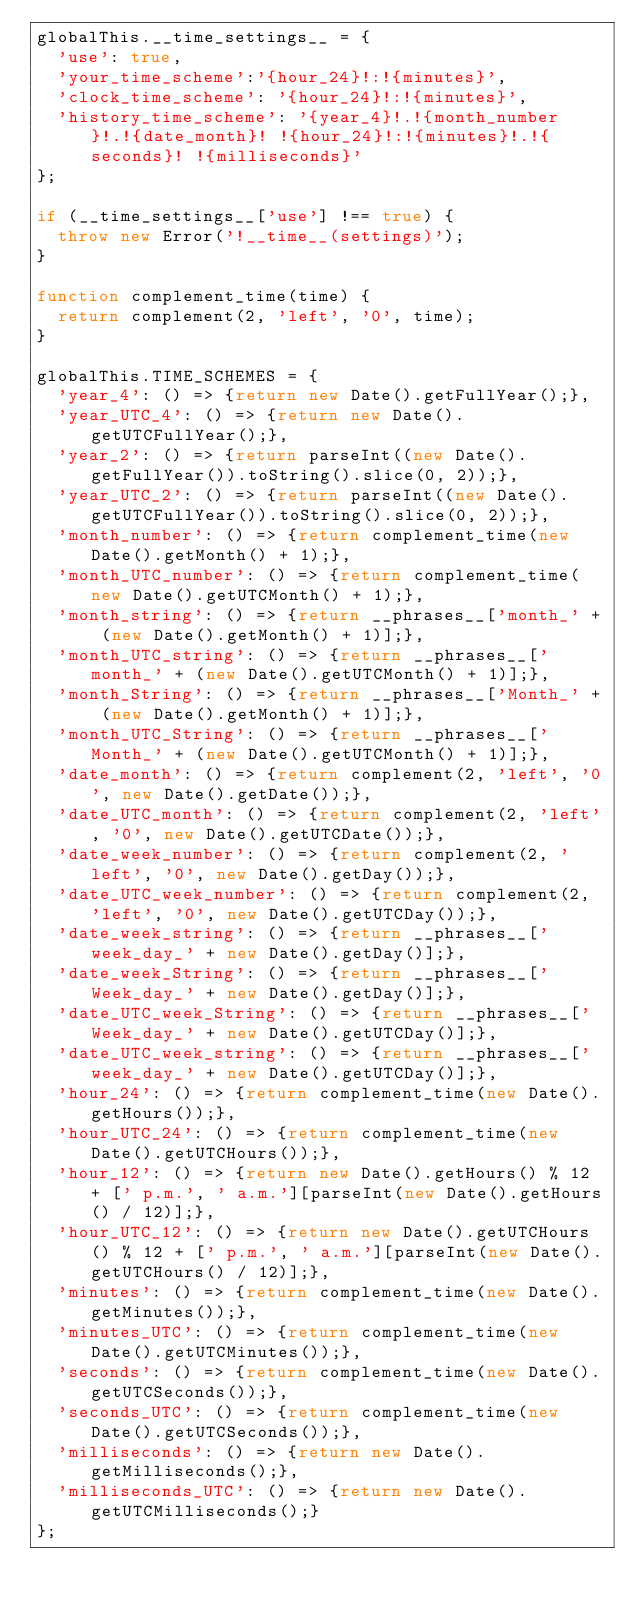Convert code to text. <code><loc_0><loc_0><loc_500><loc_500><_JavaScript_>globalThis.__time_settings__ = {
	'use': true,
	'your_time_scheme':'{hour_24}!:!{minutes}',
	'clock_time_scheme': '{hour_24}!:!{minutes}',
	'history_time_scheme': '{year_4}!.!{month_number}!.!{date_month}! !{hour_24}!:!{minutes}!.!{seconds}! !{milliseconds}'
};

if (__time_settings__['use'] !== true) {
	throw new Error('!__time__(settings)');
}

function complement_time(time) {
	return complement(2, 'left', '0', time);
}

globalThis.TIME_SCHEMES = {
	'year_4': () => {return new Date().getFullYear();},
	'year_UTC_4': () => {return new Date().getUTCFullYear();},
	'year_2': () => {return parseInt((new Date().getFullYear()).toString().slice(0, 2));},
	'year_UTC_2': () => {return parseInt((new Date().getUTCFullYear()).toString().slice(0, 2));},
	'month_number': () => {return complement_time(new Date().getMonth() + 1);},
	'month_UTC_number': () => {return complement_time(new Date().getUTCMonth() + 1);},
	'month_string': () => {return __phrases__['month_' + (new Date().getMonth() + 1)];},
	'month_UTC_string': () => {return __phrases__['month_' + (new Date().getUTCMonth() + 1)];},
	'month_String': () => {return __phrases__['Month_' + (new Date().getMonth() + 1)];},
	'month_UTC_String': () => {return __phrases__['Month_' + (new Date().getUTCMonth() + 1)];},
	'date_month': () => {return complement(2, 'left', '0', new Date().getDate());},
	'date_UTC_month': () => {return complement(2, 'left', '0', new Date().getUTCDate());},
	'date_week_number': () => {return complement(2, 'left', '0', new Date().getDay());},
	'date_UTC_week_number': () => {return complement(2, 'left', '0', new Date().getUTCDay());},
	'date_week_string': () => {return __phrases__['week_day_' + new Date().getDay()];},
	'date_week_String': () => {return __phrases__['Week_day_' + new Date().getDay()];},
	'date_UTC_week_String': () => {return __phrases__['Week_day_' + new Date().getUTCDay()];},
	'date_UTC_week_string': () => {return __phrases__['week_day_' + new Date().getUTCDay()];},
	'hour_24': () => {return complement_time(new Date().getHours());},
	'hour_UTC_24': () => {return complement_time(new Date().getUTCHours());},
	'hour_12': () => {return new Date().getHours() % 12 + [' p.m.', ' a.m.'][parseInt(new Date().getHours() / 12)];},
	'hour_UTC_12': () => {return new Date().getUTCHours() % 12 + [' p.m.', ' a.m.'][parseInt(new Date().getUTCHours() / 12)];},
	'minutes': () => {return complement_time(new Date().getMinutes());},
	'minutes_UTC': () => {return complement_time(new Date().getUTCMinutes());},
	'seconds': () => {return complement_time(new Date().getUTCSeconds());},
	'seconds_UTC': () => {return complement_time(new Date().getUTCSeconds());},
	'milliseconds': () => {return new Date().getMilliseconds();},
	'milliseconds_UTC': () => {return new Date().getUTCMilliseconds();}
};</code> 